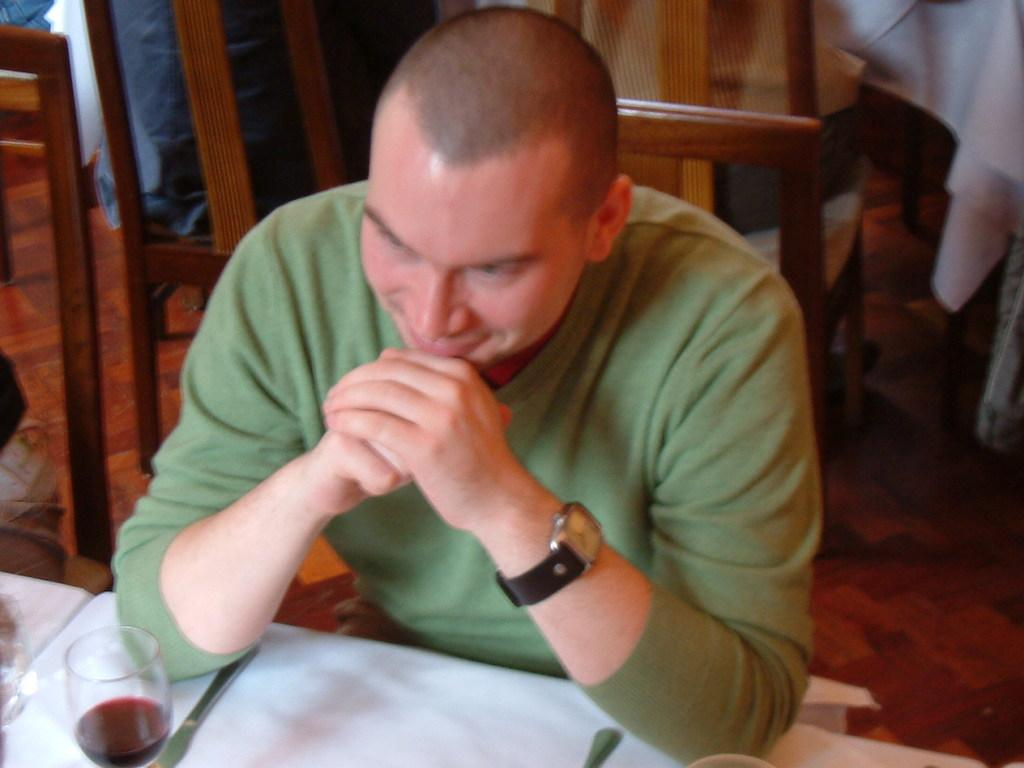Who is present in the image? There is a man in the image. What is the man doing in the image? The man is seated on a chair. What object can be seen on a table in the image? There is a wine glass on a table in the image. How many mice can be seen running up the hill in the image? There are no mice or hills present in the image; it features a man seated on a chair with a wine glass on a table. 